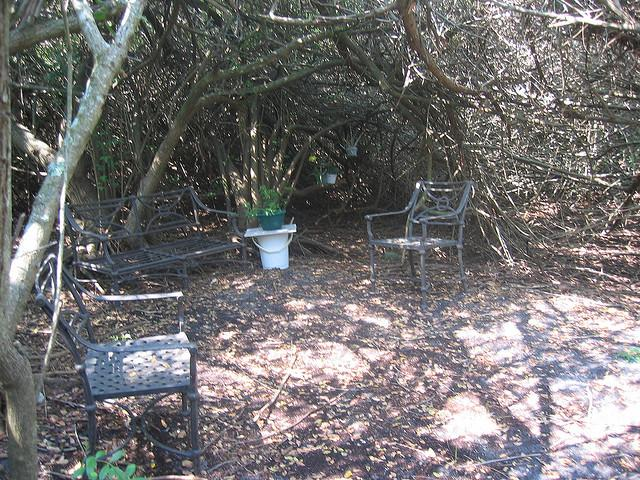What is near the flower pot? bench 